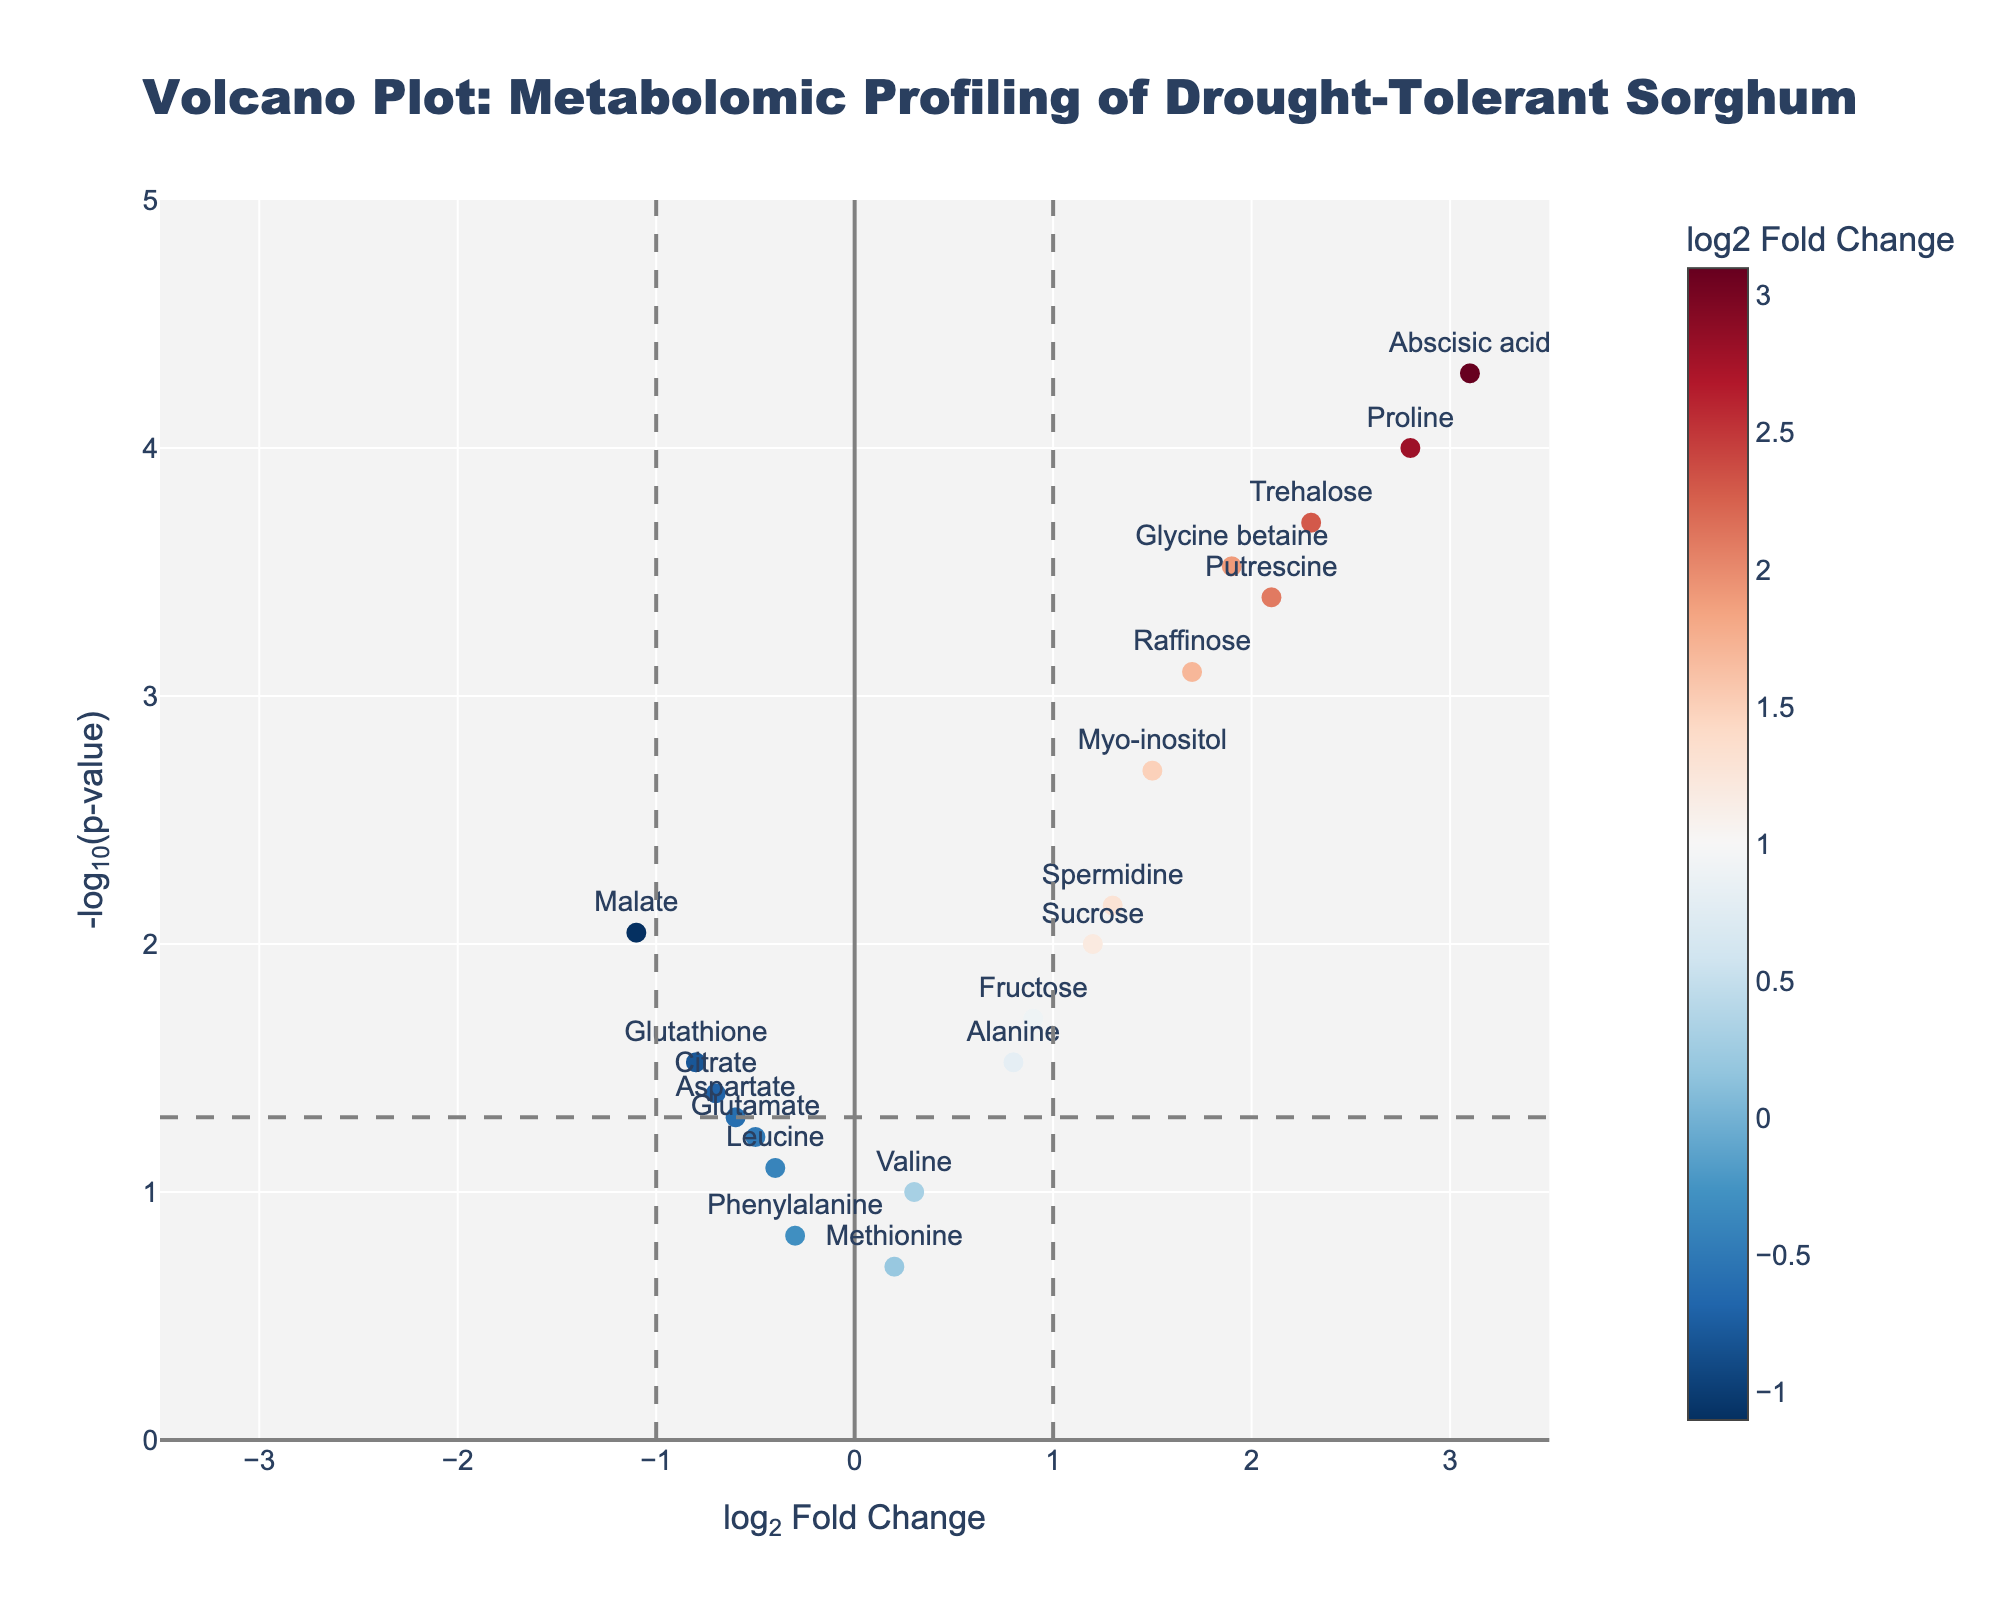How many metabolites have a log2 Fold Change greater than 1? Scan the x-axis for data points located to the right of the vertical line at x=1. Count the data points found in this region.
Answer: 9 Which metabolite has the highest log2 Fold Change? Identify the metabolite with the highest x-value by examining the x-axis. The text label at the highest x-axis value indicates the metabolite.
Answer: Abscisic acid Which metabolite has the lowest p-value? Locate the data point with the highest y-value on the plot. The metabolite label at this position represents the one with the lowest p-value.
Answer: Abscisic acid What is the range of the x-axis? Observe the x-axis and note the minimum and maximum values displayed. Subtract the minimum value from the maximum value to determine the range.
Answer: -3.5 to 3.5 How many metabolites have a p-value less than 0.05? Identify data points above the horizontal line at y=-log10(0.05). Count all these points since they represent metabolites with p-values below this threshold.
Answer: 11 Which metabolites have a negative log2 Fold Change and a p-value less than 0.05? Look for data points to the left of x=0 with a y-value above -log10(0.05). Note the metabolite labels for these points.
Answer: Malate, Glutathione What do the colors of the data points represent? Check the color legend or bar associated with the plot. The title of the color bar indicates the parameter it represents.
Answer: log2 Fold Change Compare the log2 Fold Change of Proline and Glycine betaine. Which one is higher? Identify the log2 Fold Change values for Proline and Glycine betaine on the plot. Compare these two values.
Answer: Proline Do any metabolites have both a log2 Fold Change less than -1 and a p-value less than 0.05? Examine the data points left of the x=-1 vertical line and above the horizontal line at -log10(0.05). Check if there are any such points.
Answer: No 